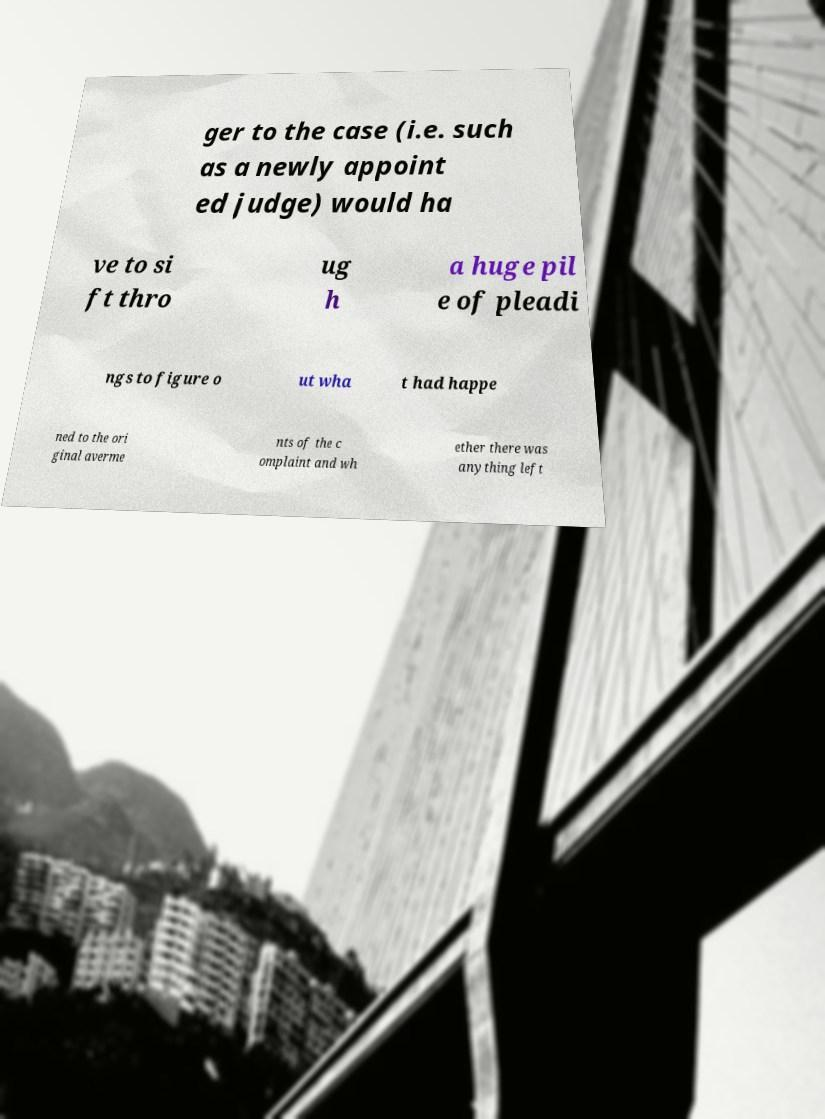Can you accurately transcribe the text from the provided image for me? ger to the case (i.e. such as a newly appoint ed judge) would ha ve to si ft thro ug h a huge pil e of pleadi ngs to figure o ut wha t had happe ned to the ori ginal averme nts of the c omplaint and wh ether there was anything left 